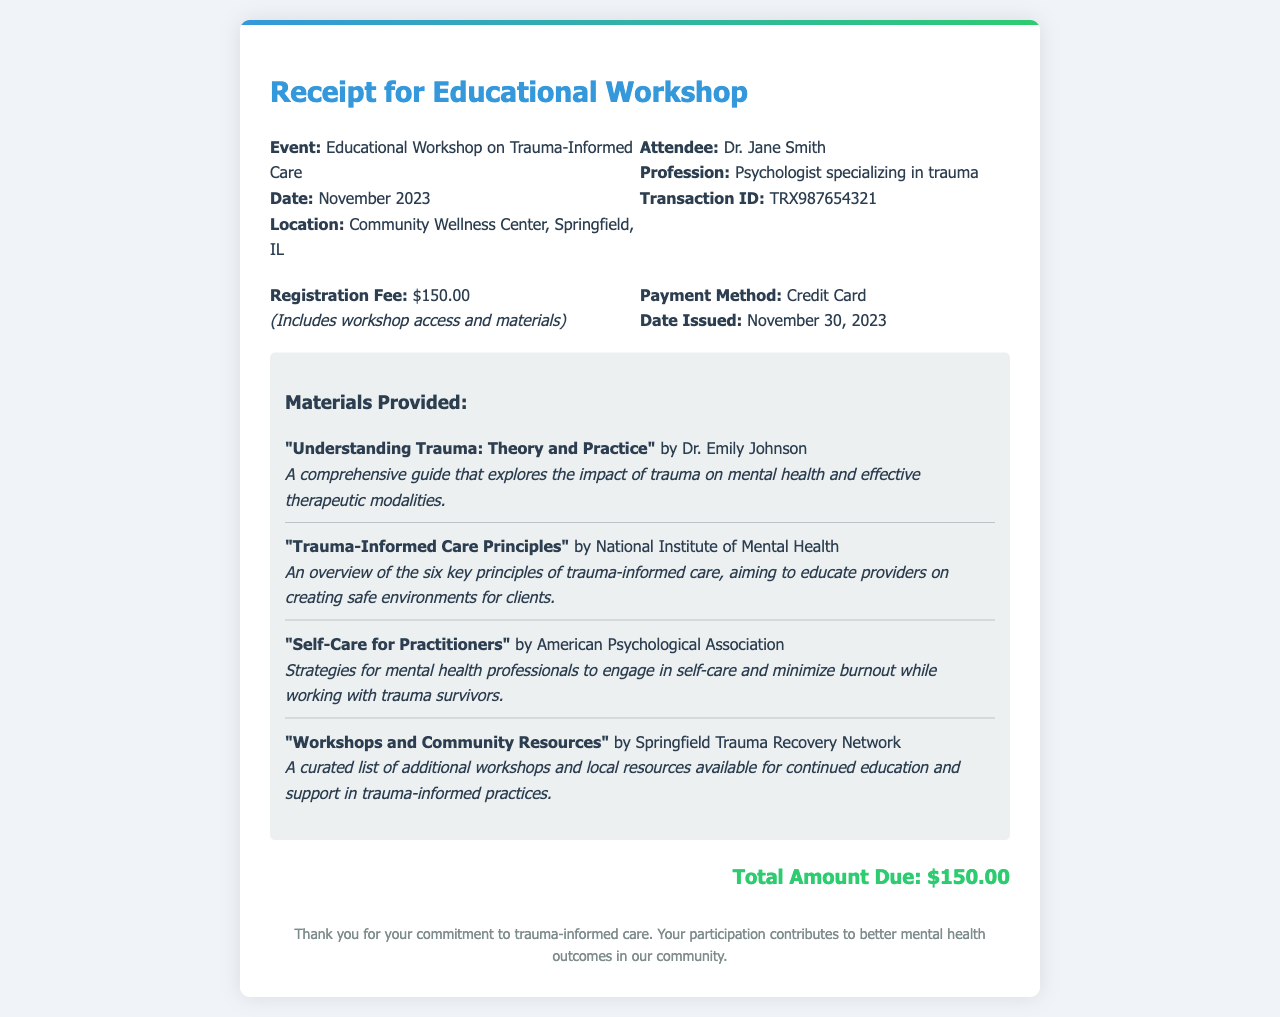What is the event title? The event title is presented prominently in the document, indicating the focus of the workshop attended.
Answer: Educational Workshop on Trauma-Informed Care When did the workshop take place? The date of the workshop is mentioned clearly in the receipt, specifying when the attendance occurred.
Answer: November 2023 Who attended the workshop? The name of the attendee is highlighted in the document, identifying who participated in the event.
Answer: Dr. Jane Smith What was the registration fee? The registration fee is specified in the receipt, detailing the cost for attending the workshop.
Answer: $150.00 What materials were provided? The specific materials provided during the workshop are listed, showcasing the resources available to participants.
Answer: "Understanding Trauma: Theory and Practice", "Trauma-Informed Care Principles", "Self-Care for Practitioners", "Workshops and Community Resources" What payment method was used? The method of payment for the registration fee is indicated in the document, providing insight into how the transaction was completed.
Answer: Credit Card What is the total amount due? The total amount due is clearly stated at the bottom of the receipt, summarizing the financial obligation.
Answer: $150.00 Where was the workshop held? The location is detailed in the document, indicating where the event took place.
Answer: Community Wellness Center, Springfield, IL What is the transaction ID? The transaction ID is provided in the receipt for tracking the financial transaction related to the workshop.
Answer: TRX987654321 